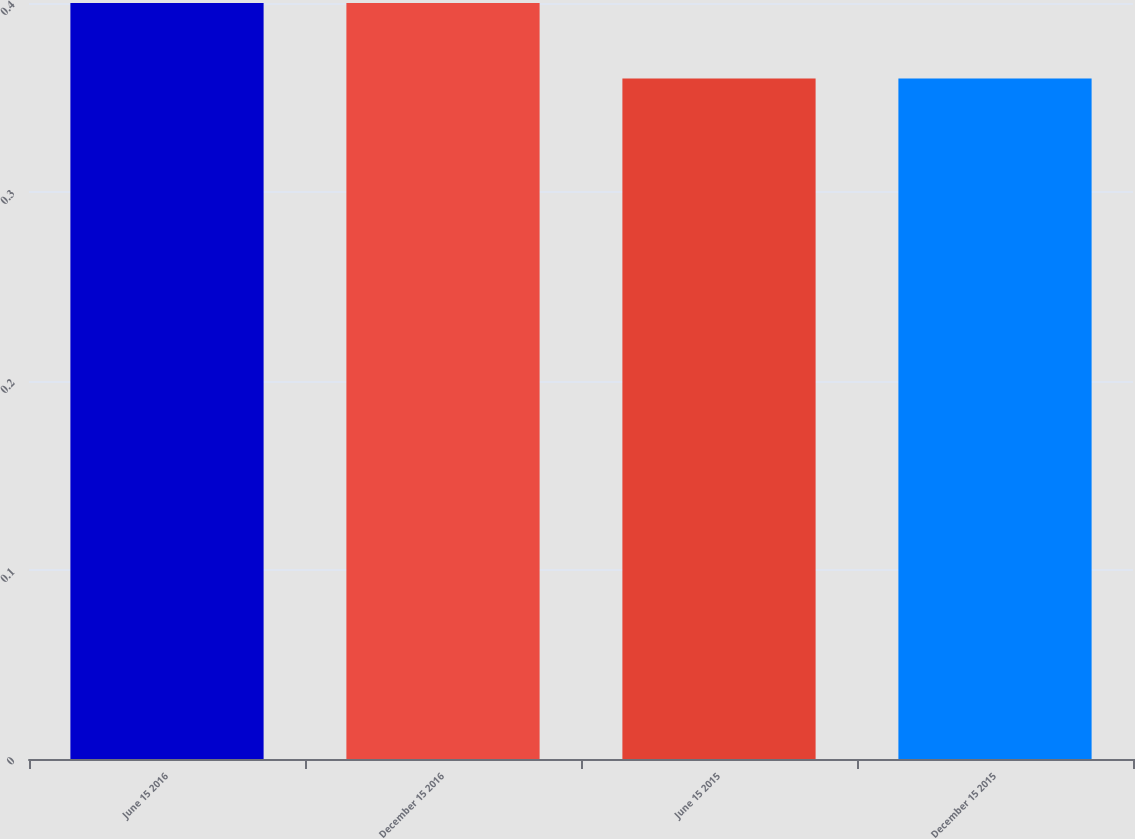Convert chart. <chart><loc_0><loc_0><loc_500><loc_500><bar_chart><fcel>June 15 2016<fcel>December 15 2016<fcel>June 15 2015<fcel>December 15 2015<nl><fcel>0.4<fcel>0.4<fcel>0.36<fcel>0.36<nl></chart> 